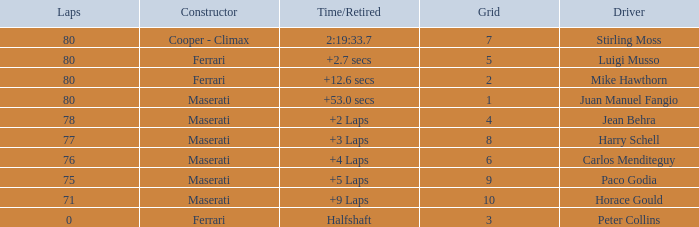What were the lowest laps of Luigi Musso driving a Ferrari with a Grid larger than 2? 80.0. Can you parse all the data within this table? {'header': ['Laps', 'Constructor', 'Time/Retired', 'Grid', 'Driver'], 'rows': [['80', 'Cooper - Climax', '2:19:33.7', '7', 'Stirling Moss'], ['80', 'Ferrari', '+2.7 secs', '5', 'Luigi Musso'], ['80', 'Ferrari', '+12.6 secs', '2', 'Mike Hawthorn'], ['80', 'Maserati', '+53.0 secs', '1', 'Juan Manuel Fangio'], ['78', 'Maserati', '+2 Laps', '4', 'Jean Behra'], ['77', 'Maserati', '+3 Laps', '8', 'Harry Schell'], ['76', 'Maserati', '+4 Laps', '6', 'Carlos Menditeguy'], ['75', 'Maserati', '+5 Laps', '9', 'Paco Godia'], ['71', 'Maserati', '+9 Laps', '10', 'Horace Gould'], ['0', 'Ferrari', 'Halfshaft', '3', 'Peter Collins']]} 